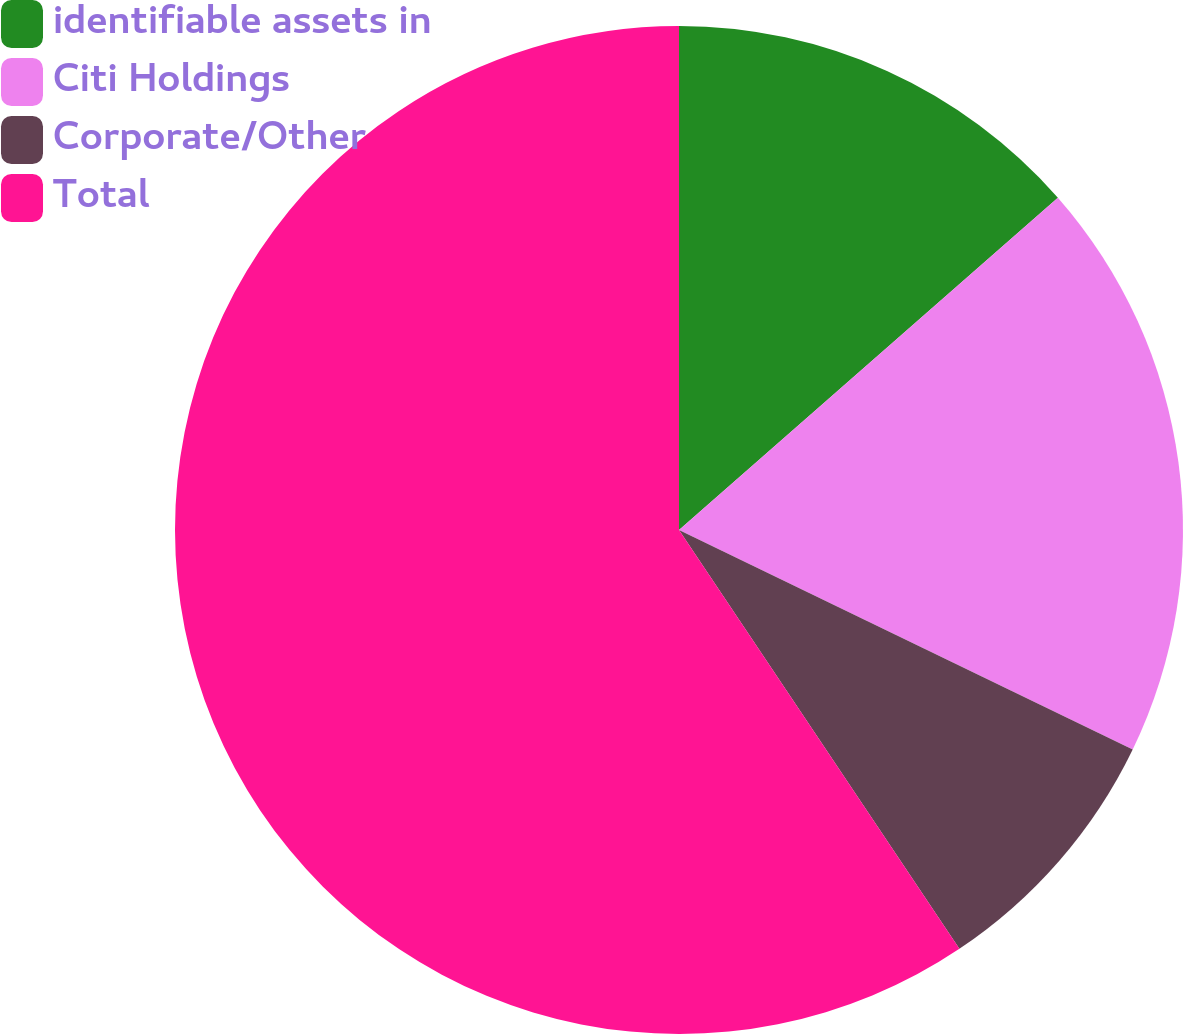<chart> <loc_0><loc_0><loc_500><loc_500><pie_chart><fcel>identifiable assets in<fcel>Citi Holdings<fcel>Corporate/Other<fcel>Total<nl><fcel>13.54%<fcel>18.63%<fcel>8.44%<fcel>59.39%<nl></chart> 